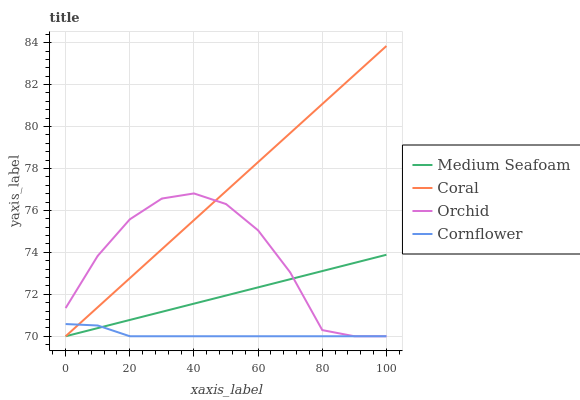Does Medium Seafoam have the minimum area under the curve?
Answer yes or no. No. Does Medium Seafoam have the maximum area under the curve?
Answer yes or no. No. Is Coral the smoothest?
Answer yes or no. No. Is Coral the roughest?
Answer yes or no. No. Does Medium Seafoam have the highest value?
Answer yes or no. No. 